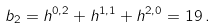Convert formula to latex. <formula><loc_0><loc_0><loc_500><loc_500>b _ { 2 } = h ^ { 0 , 2 } + h ^ { 1 , 1 } + h ^ { 2 , 0 } = 1 9 \, .</formula> 